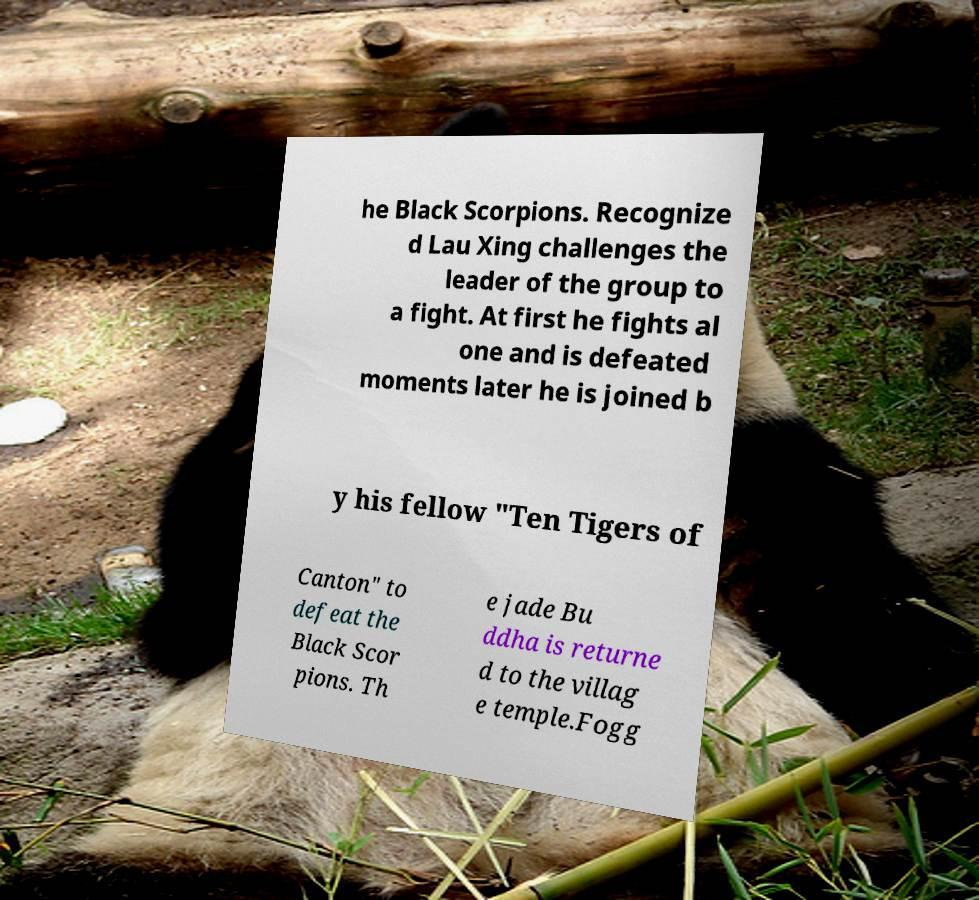Could you extract and type out the text from this image? he Black Scorpions. Recognize d Lau Xing challenges the leader of the group to a fight. At first he fights al one and is defeated moments later he is joined b y his fellow "Ten Tigers of Canton" to defeat the Black Scor pions. Th e jade Bu ddha is returne d to the villag e temple.Fogg 